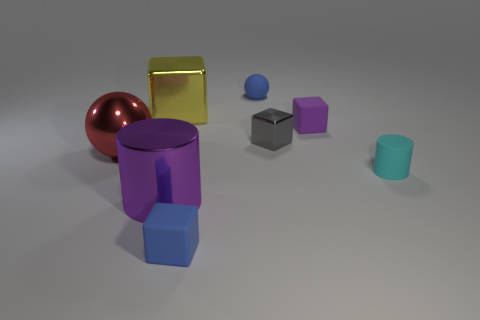Is the material of the yellow object the same as the small gray cube?
Make the answer very short. Yes. What number of other objects are the same material as the small sphere?
Keep it short and to the point. 3. What shape is the large red object that is the same material as the big yellow object?
Your answer should be compact. Sphere. Is there any other thing of the same color as the tiny matte cylinder?
Keep it short and to the point. No. How many blue things are there?
Offer a very short reply. 2. The object that is on the right side of the purple metallic thing and in front of the cyan matte cylinder has what shape?
Provide a short and direct response. Cube. What is the shape of the purple thing right of the tiny blue thing that is to the right of the tiny rubber block in front of the big red thing?
Your answer should be compact. Cube. What is the object that is both behind the tiny purple rubber block and in front of the tiny ball made of?
Your response must be concise. Metal. How many cubes are the same size as the metallic sphere?
Give a very brief answer. 1. How many shiny objects are large purple objects or yellow blocks?
Ensure brevity in your answer.  2. 